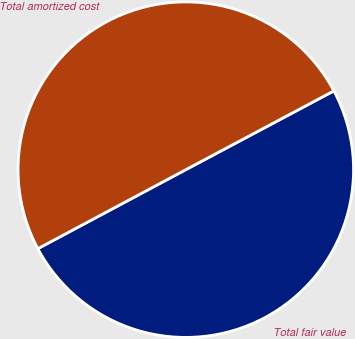Convert chart. <chart><loc_0><loc_0><loc_500><loc_500><pie_chart><fcel>Total fair value<fcel>Total amortized cost<nl><fcel>49.98%<fcel>50.02%<nl></chart> 